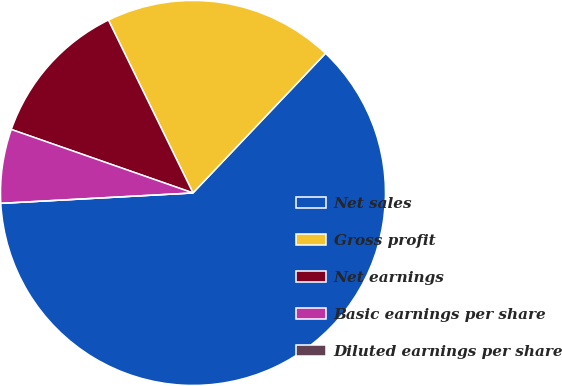Convert chart. <chart><loc_0><loc_0><loc_500><loc_500><pie_chart><fcel>Net sales<fcel>Gross profit<fcel>Net earnings<fcel>Basic earnings per share<fcel>Diluted earnings per share<nl><fcel>62.06%<fcel>19.33%<fcel>12.41%<fcel>6.21%<fcel>0.0%<nl></chart> 